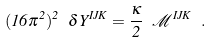<formula> <loc_0><loc_0><loc_500><loc_500>( 1 6 \pi ^ { 2 } ) ^ { 2 } \ \delta Y ^ { I J K } = \frac { \kappa } 2 \ \mathcal { M } ^ { I J K } \ .</formula> 